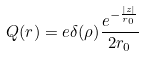<formula> <loc_0><loc_0><loc_500><loc_500>Q ( r ) = e \delta ( \rho ) \frac { e ^ { - \frac { | z | } { r _ { 0 } } } } { 2 r _ { 0 } }</formula> 